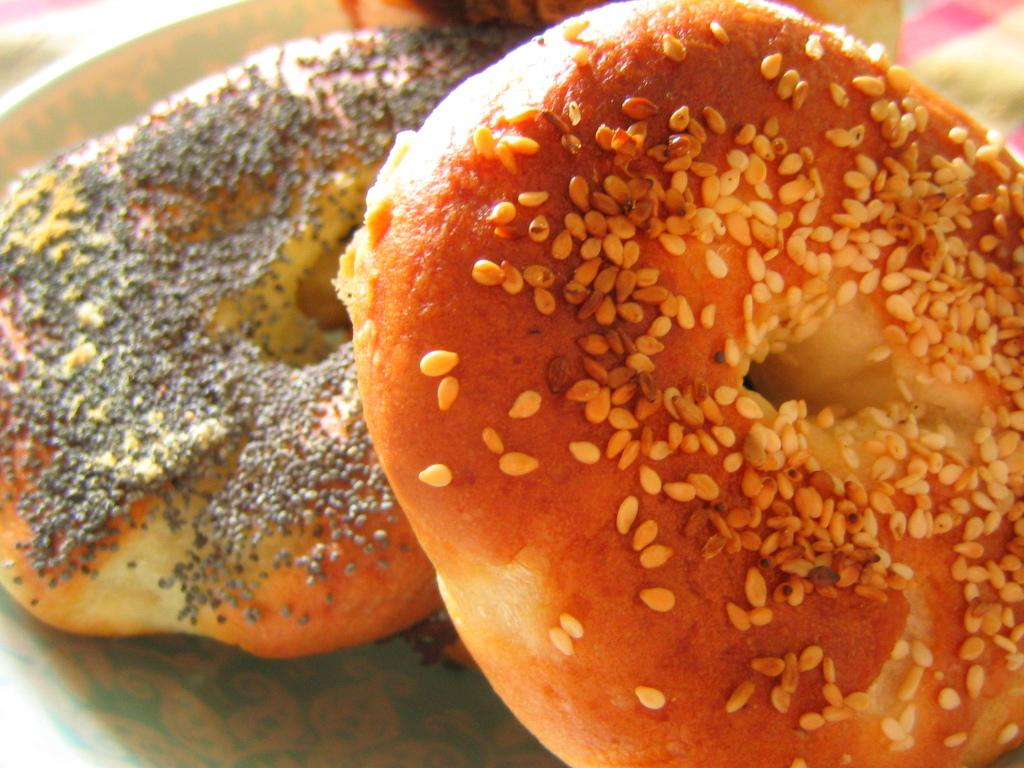What type of food item is visible in the image? There is a food item in the image, and it looks like a doughnut. What type of salt can be seen sprinkled on the doughnut in the image? There is no salt visible on the doughnut in the image. What type of flock is flying around the doughnut in the image? There is no flock present in the image. What type of pipe is connected to the doughnut in the image? There is no pipe connected to the doughnut in the image. 